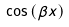<formula> <loc_0><loc_0><loc_500><loc_500>\cos \left ( \beta x \right )</formula> 